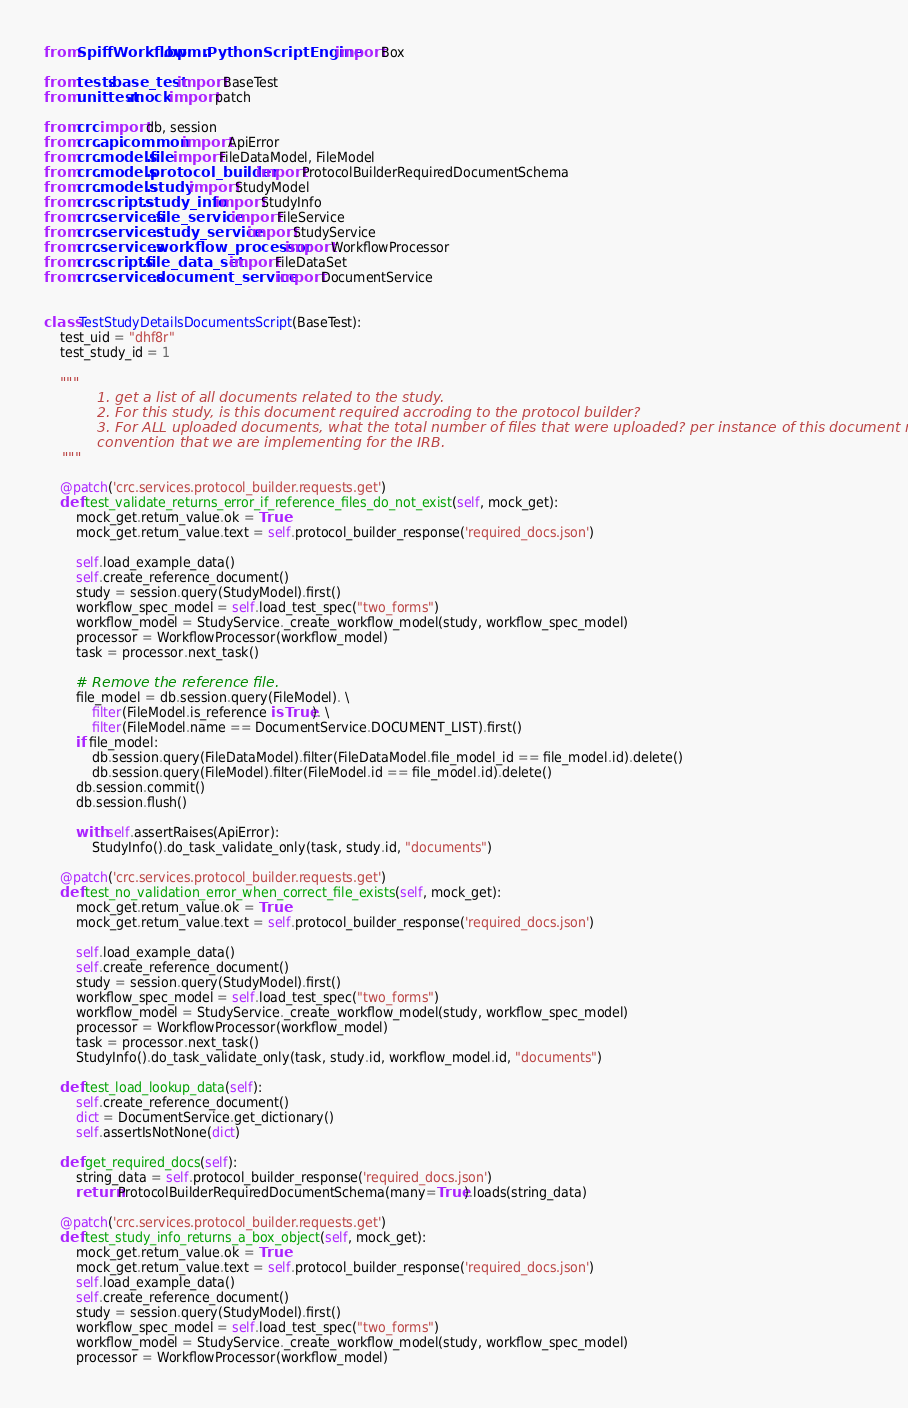Convert code to text. <code><loc_0><loc_0><loc_500><loc_500><_Python_>
from SpiffWorkflow.bpmn.PythonScriptEngine import Box

from tests.base_test import BaseTest
from unittest.mock import patch

from crc import db, session
from crc.api.common import ApiError
from crc.models.file import FileDataModel, FileModel
from crc.models.protocol_builder import ProtocolBuilderRequiredDocumentSchema
from crc.models.study import StudyModel
from crc.scripts.study_info import StudyInfo
from crc.services.file_service import FileService
from crc.services.study_service import StudyService
from crc.services.workflow_processor import WorkflowProcessor
from crc.scripts.file_data_set import FileDataSet
from crc.services.document_service import DocumentService


class TestStudyDetailsDocumentsScript(BaseTest):
    test_uid = "dhf8r"
    test_study_id = 1

    """
            1. get a list of all documents related to the study.
            2. For this study, is this document required accroding to the protocol builder?
            3. For ALL uploaded documents, what the total number of files that were uploaded? per instance of this document naming
            convention that we are implementing for the IRB.
    """

    @patch('crc.services.protocol_builder.requests.get')
    def test_validate_returns_error_if_reference_files_do_not_exist(self, mock_get):
        mock_get.return_value.ok = True
        mock_get.return_value.text = self.protocol_builder_response('required_docs.json')

        self.load_example_data()
        self.create_reference_document()
        study = session.query(StudyModel).first()
        workflow_spec_model = self.load_test_spec("two_forms")
        workflow_model = StudyService._create_workflow_model(study, workflow_spec_model)
        processor = WorkflowProcessor(workflow_model)
        task = processor.next_task()

        # Remove the reference file.
        file_model = db.session.query(FileModel). \
            filter(FileModel.is_reference is True). \
            filter(FileModel.name == DocumentService.DOCUMENT_LIST).first()
        if file_model:
            db.session.query(FileDataModel).filter(FileDataModel.file_model_id == file_model.id).delete()
            db.session.query(FileModel).filter(FileModel.id == file_model.id).delete()
        db.session.commit()
        db.session.flush()

        with self.assertRaises(ApiError):
            StudyInfo().do_task_validate_only(task, study.id, "documents")

    @patch('crc.services.protocol_builder.requests.get')
    def test_no_validation_error_when_correct_file_exists(self, mock_get):
        mock_get.return_value.ok = True
        mock_get.return_value.text = self.protocol_builder_response('required_docs.json')

        self.load_example_data()
        self.create_reference_document()
        study = session.query(StudyModel).first()
        workflow_spec_model = self.load_test_spec("two_forms")
        workflow_model = StudyService._create_workflow_model(study, workflow_spec_model)
        processor = WorkflowProcessor(workflow_model)
        task = processor.next_task()
        StudyInfo().do_task_validate_only(task, study.id, workflow_model.id, "documents")

    def test_load_lookup_data(self):
        self.create_reference_document()
        dict = DocumentService.get_dictionary()
        self.assertIsNotNone(dict)

    def get_required_docs(self):
        string_data = self.protocol_builder_response('required_docs.json')
        return ProtocolBuilderRequiredDocumentSchema(many=True).loads(string_data)

    @patch('crc.services.protocol_builder.requests.get')
    def test_study_info_returns_a_box_object(self, mock_get):
        mock_get.return_value.ok = True
        mock_get.return_value.text = self.protocol_builder_response('required_docs.json')
        self.load_example_data()
        self.create_reference_document()
        study = session.query(StudyModel).first()
        workflow_spec_model = self.load_test_spec("two_forms")
        workflow_model = StudyService._create_workflow_model(study, workflow_spec_model)
        processor = WorkflowProcessor(workflow_model)</code> 